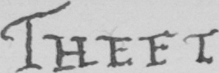Can you tell me what this handwritten text says? THEFT 